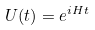Convert formula to latex. <formula><loc_0><loc_0><loc_500><loc_500>U ( t ) = e ^ { i H t }</formula> 